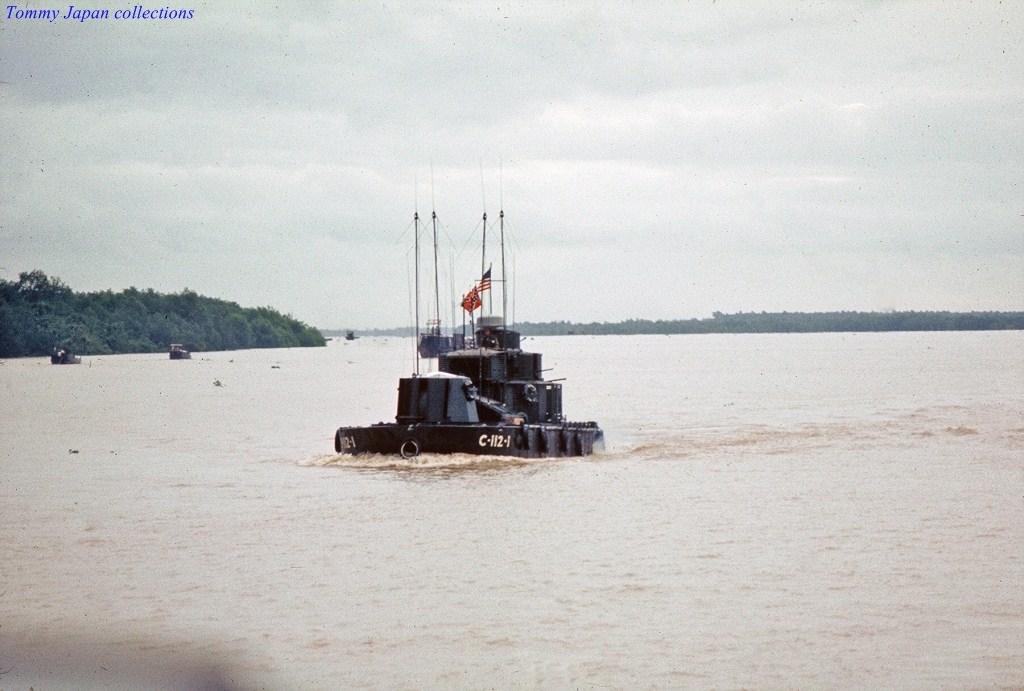Whose collection is this from?
Ensure brevity in your answer.  Tommy japan. What is the number on the boat?
Provide a short and direct response. C-112-1. 